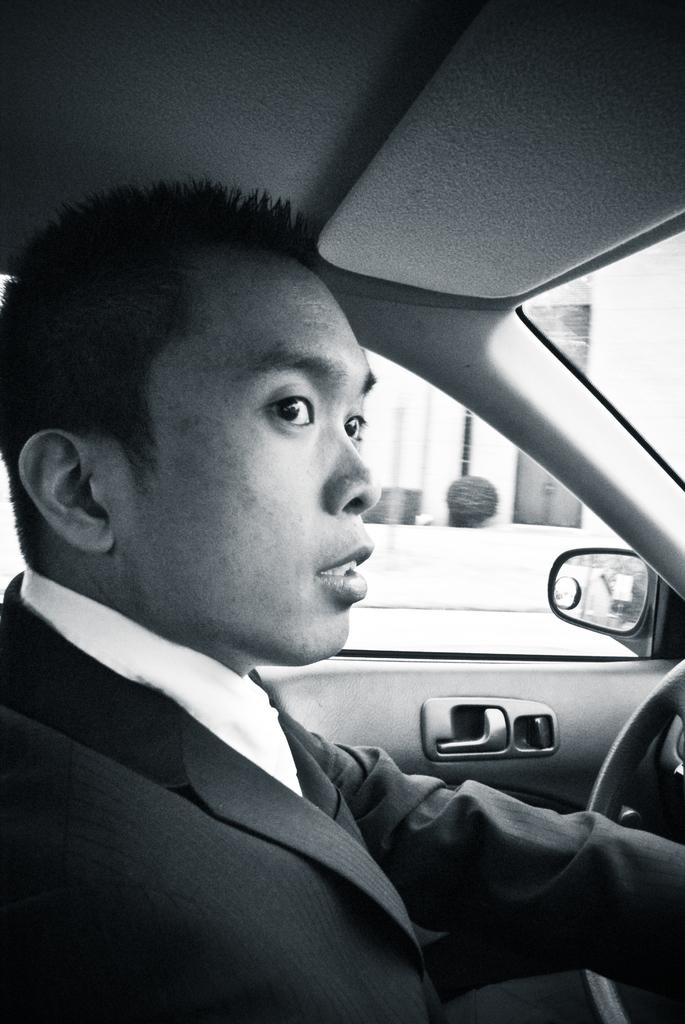What is the man doing in the image? The man is sitting inside a car. What is the man wearing in the image? The man is wearing a coat and a white shirt. What can be seen through the car window? A building and a plant can be seen through the car window. What is the status of the car door? The car door is closed. What route is the chair taking in the image? There is no chair present in the image, so it cannot be taking any route. 